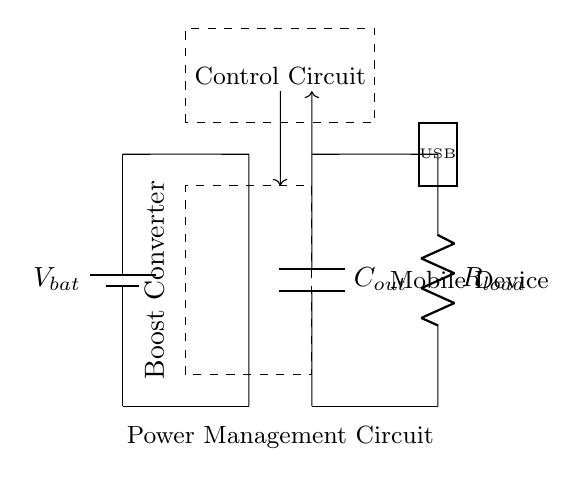What is the type of the power source in the circuit? The circuit uses a battery as the power source, indicated by the symbol labeled as Vbat.
Answer: battery What is the purpose of the boost converter in this circuit? The boost converter increases the voltage from the battery to the level required to charge a mobile device. This is essential because mobile devices typically require a higher voltage than the battery provides.
Answer: increase voltage What component is connected to the output of the boost converter? The output capacitor, labeled as Cout, is directly connected to the output of the boost converter to store and stabilize the voltage.
Answer: output capacitor What load is represented in the circuit diagram? The circuit includes a resistor labeled Rload, which represents the load, such as a mobile device being charged.
Answer: resistor How does the control circuit function in relation to the boost converter? The control circuit regulates the operation of the boost converter by providing feedback based on the output voltage, ensuring stable charging conditions for the mobile device.
Answer: regulates operation What does the dashed box enclosing the boost converter and control circuit indicate? The dashed box signifies that these components are functionally grouped together within the power management circuit, often indicating they work in conjunction for voltage regulation.
Answer: functional grouping What type of output does this circuit provide for mobile devices? The circuit provides a USB output, as indicated by the rectangle labeled USB, commonly used for charging smartphones and tablets.
Answer: USB output 